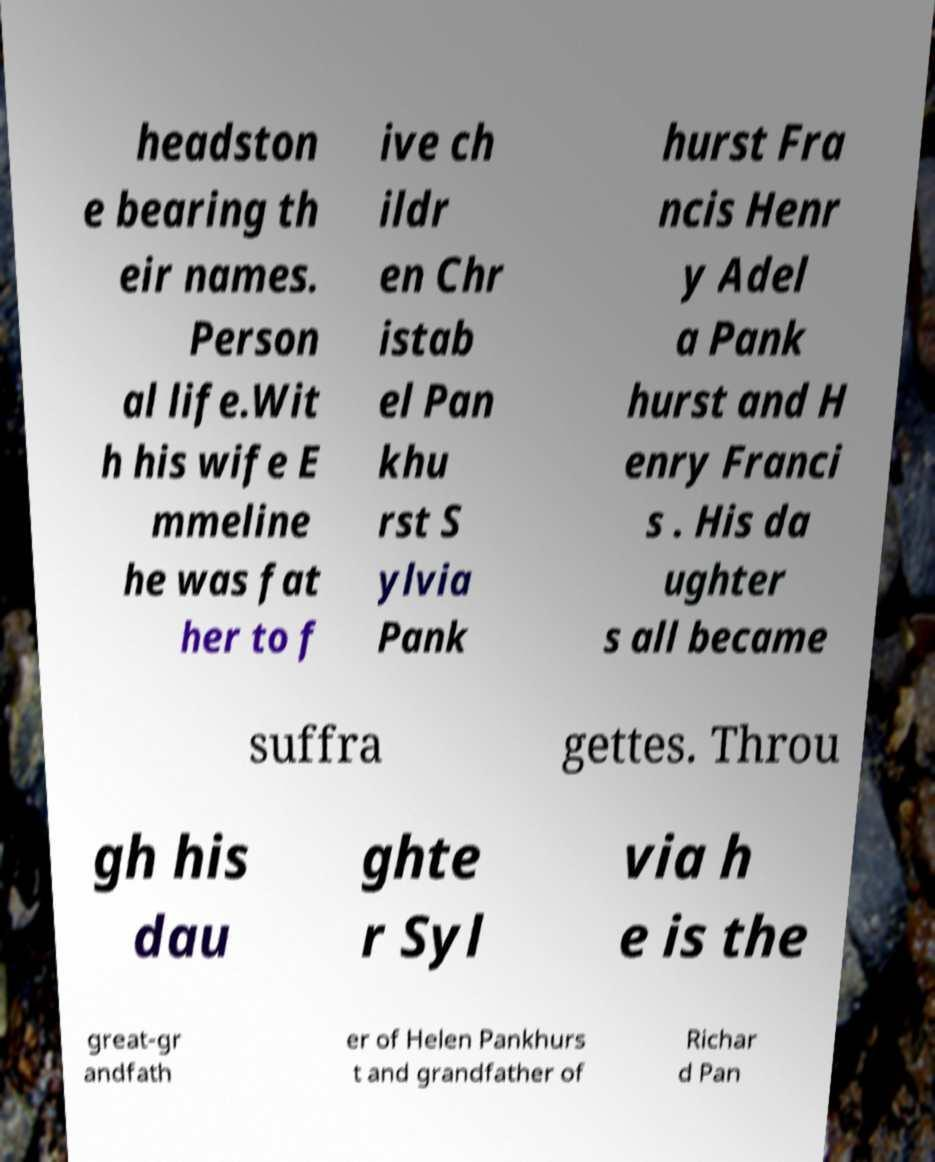Please identify and transcribe the text found in this image. headston e bearing th eir names. Person al life.Wit h his wife E mmeline he was fat her to f ive ch ildr en Chr istab el Pan khu rst S ylvia Pank hurst Fra ncis Henr y Adel a Pank hurst and H enry Franci s . His da ughter s all became suffra gettes. Throu gh his dau ghte r Syl via h e is the great-gr andfath er of Helen Pankhurs t and grandfather of Richar d Pan 